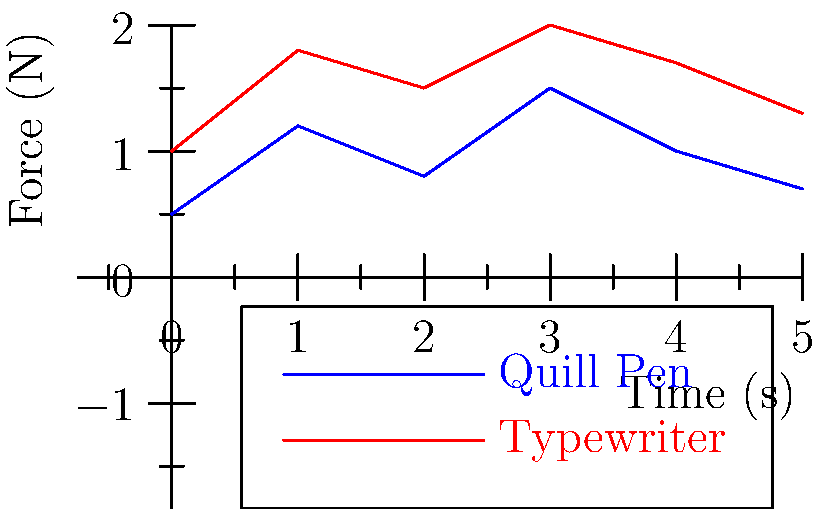Based on the graph showing the force applied over time for handwriting with a quill pen versus typing on an early typewriter, which writing method consistently requires more force throughout the writing process? How might this difference in force application relate to the efficiency and fatigue experienced by writers during the transition from handwritten to typed documents in the Victorian era? To answer this question, we need to analyze the graph step-by-step:

1. The blue line represents the force applied when writing with a quill pen, while the red line represents the force applied when using an early typewriter.

2. Observe the relative positions of the two lines:
   - At every time point, the red line (typewriter) is higher than the blue line (quill pen).
   - This indicates that the typewriter consistently requires more force than the quill pen.

3. Calculate the average force for each method:
   - Quill pen: $(0.5 + 1.2 + 0.8 + 1.5 + 1.0 + 0.7) / 6 \approx 0.95$ N
   - Typewriter: $(1.0 + 1.8 + 1.5 + 2.0 + 1.7 + 1.3) / 6 \approx 1.55$ N

4. The typewriter requires, on average, about 63% more force than the quill pen.

5. Relating to the Victorian era:
   - Higher force requirement for typewriters could lead to increased fatigue over long writing sessions.
   - However, typewriters allowed for faster writing speeds and more legible text.
   - The trade-off between increased force and improved efficiency might have influenced the adoption rate of typewriters.
   - Writers may have experienced a period of adaptation as they transitioned from quill pens to typewriters, potentially affecting their writing style and output.

6. Cultural implications:
   - The shift to typewriters may have democratized writing, as it required less skill than beautiful penmanship.
   - The increased force but improved efficiency of typewriters could be seen as a metaphor for industrialization: more mechanical effort for greater output.
Answer: Typewriter; increased force but improved efficiency parallels industrial progress. 